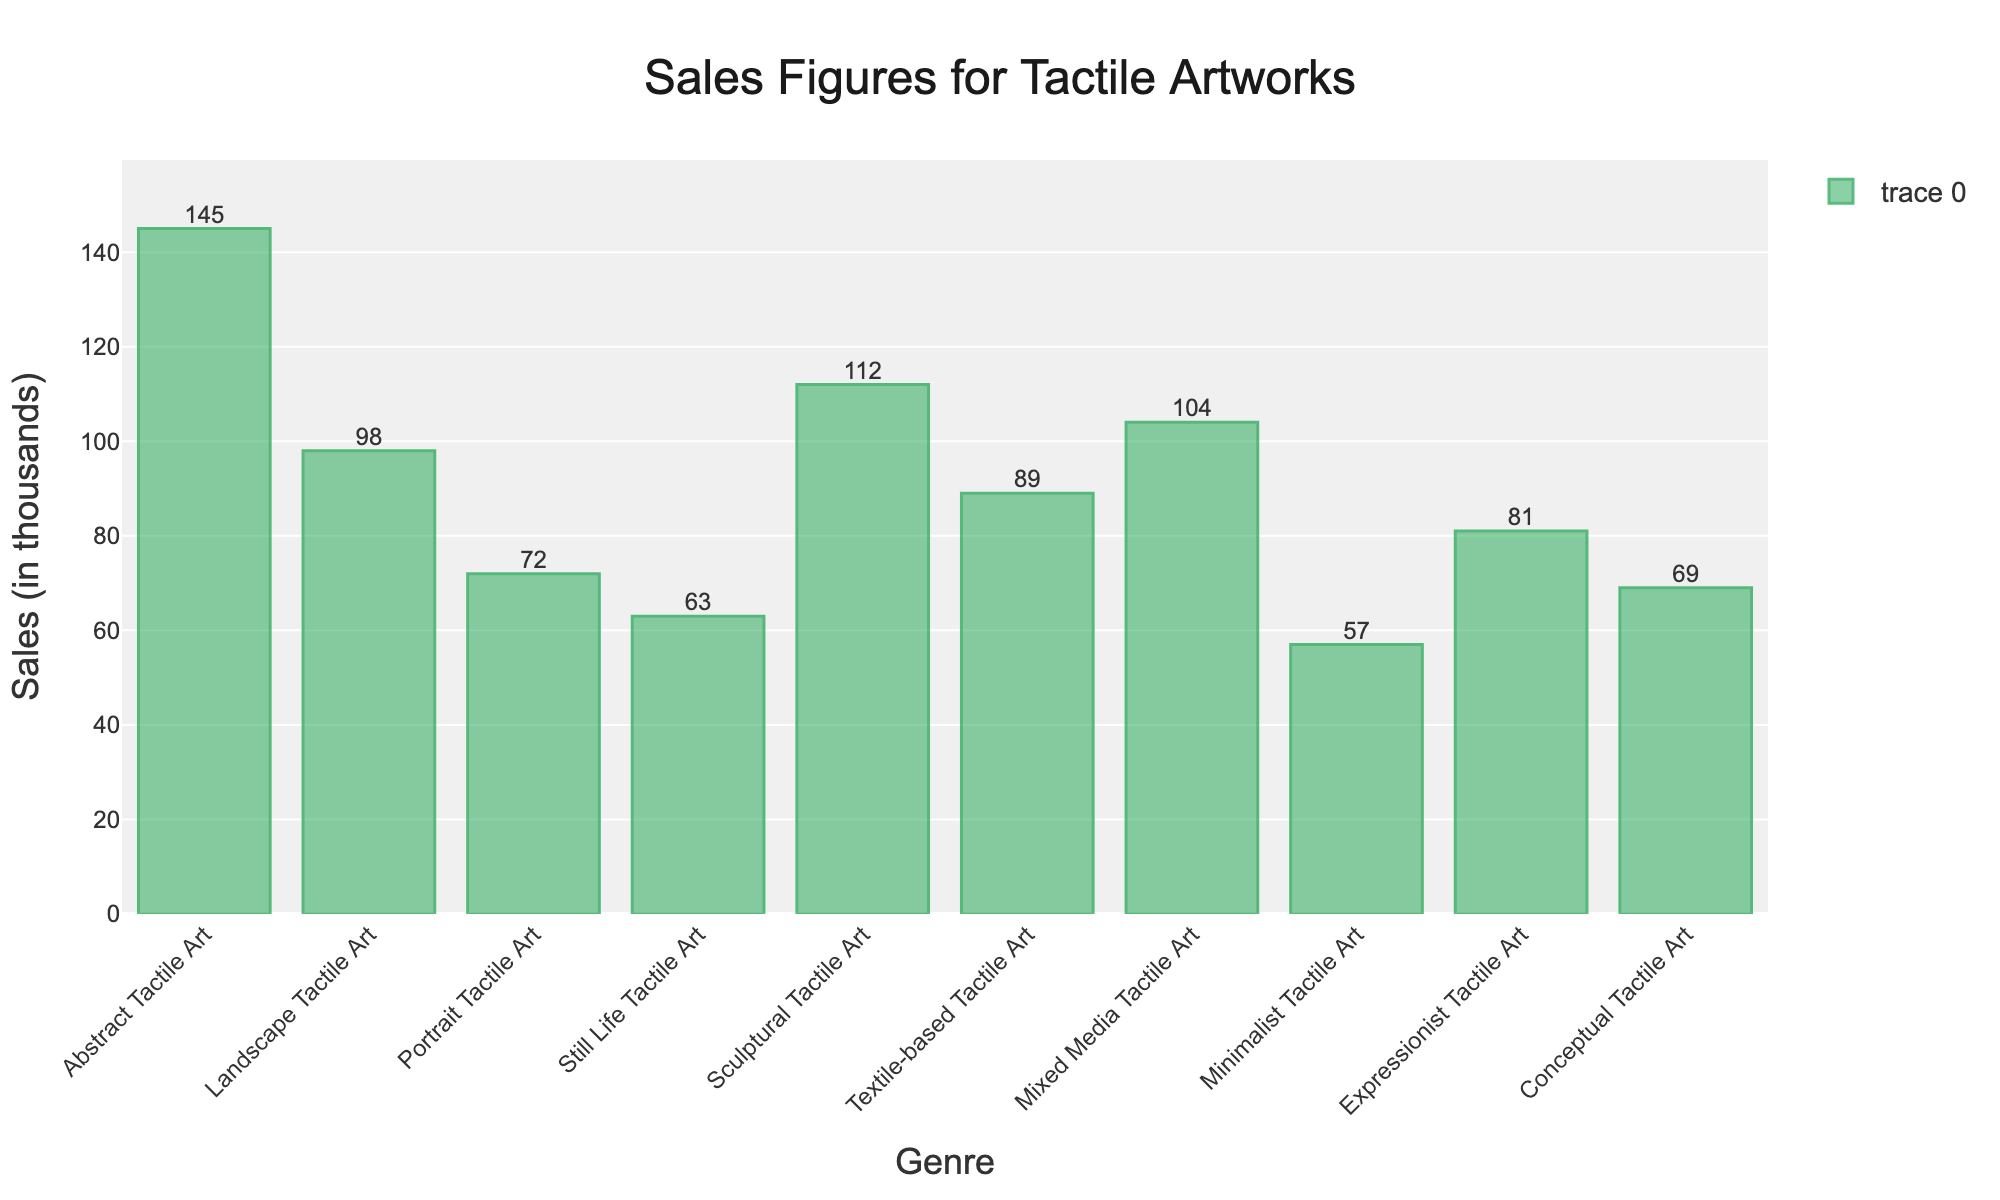what's the total sales for all genres combined? To find the total, sum all the sales figures: 145 + 98 + 72 + 63 + 112 + 89 + 104 + 57 + 81 + 69 = 890 thousands.
Answer: 890 which genre has the highest sales? The highest sales figure is 145, which corresponds to Abstract Tactile Art.
Answer: Abstract Tactile Art compare the sales of Sculptural Tactile Art and Textile-based Tactile Art. Which one is higher? Sculptural Tactile Art has 112 thousands in sales, and Textile-based Tactile Art has 89 thousands. Since 112 > 89, Sculptural Tactile Art has higher sales.
Answer: Sculptural Tactile Art what's the difference in sales between the highest and lowest-selling genres? The highest sales figure is 145 (Abstract Tactile Art) and the lowest is 57 (Minimalist Tactile Art). The difference is 145 - 57 = 88 thousands.
Answer: 88 is there any genre whose sales are equal or nearly equal to the average sales of all genres? The average sales is the total sales divided by the number of genres: 890 / 10 = 89 thousands. Textile-based Tactile Art has sales of 89 thousands, which equals the average.
Answer: Textile-based Tactile Art which genres have sales less than 70 thousands? The genres with sales less than 70 are: Portrait Tactile Art (72 thousands), Still Life Tactile Art (63 thousands), Minimalist Tactile Art (57 thousands) and Conceptual Tactile Art (69 thousands).
Answer: Portrait Tactile Art, Still Life Tactile Art, Minimalist Tactile Art, and Conceptual Tactile Art what's the sales range shown in the chart? The sales range is calculated as the difference between the maximum and minimum sales figures. The highest sales figure is 145 and the lowest is 57. So, the range is 145 - 57 = 88 thousands.
Answer: 88 which genre's bar is visually the shortest, and what is its height? The shortest bar represents Minimalist Tactile Art with a height corresponding to 57 thousands in sales.
Answer: Minimalist Tactile Art, 57 what's the median sales value of the genres? To find the median, list the sales figures in ascending order: 57, 63, 69, 72, 81, 89, 98, 104, 112, 145. The median value is the average of the 5th and 6th values: (81 + 89) / 2 = 85 thousands.
Answer: 85 how much more does Abstract Tactile Art sell compared to the average sales of all genres? The average sales is 89 thousands. Abstract Tactile Art has sales of 145 thousands. So, it sells 145 - 89 = 56 thousands more than the average.
Answer: 56 